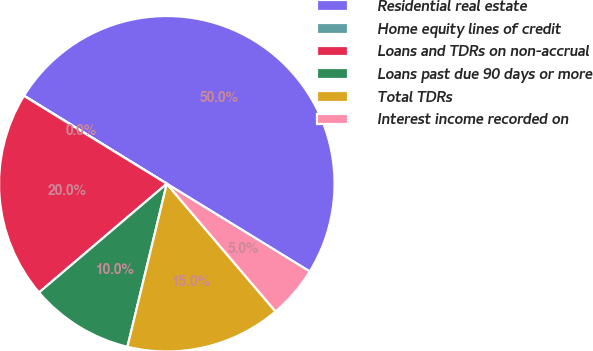Convert chart. <chart><loc_0><loc_0><loc_500><loc_500><pie_chart><fcel>Residential real estate<fcel>Home equity lines of credit<fcel>Loans and TDRs on non-accrual<fcel>Loans past due 90 days or more<fcel>Total TDRs<fcel>Interest income recorded on<nl><fcel>49.97%<fcel>0.02%<fcel>20.0%<fcel>10.01%<fcel>15.0%<fcel>5.01%<nl></chart> 